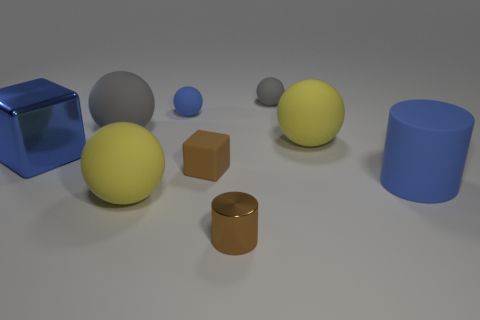There is a gray rubber object right of the big ball behind the big yellow thing that is on the right side of the tiny gray rubber thing; what shape is it?
Give a very brief answer. Sphere. There is a big thing that is right of the tiny blue object and behind the large blue cylinder; what is its shape?
Offer a terse response. Sphere. Is there a large brown cube made of the same material as the big blue cylinder?
Your answer should be very brief. No. What is the size of the rubber sphere that is the same color as the metal cube?
Provide a succinct answer. Small. The cylinder that is on the right side of the small gray matte thing is what color?
Offer a terse response. Blue. Is the shape of the big shiny object the same as the yellow rubber thing right of the tiny gray sphere?
Offer a very short reply. No. Are there any small blocks of the same color as the big metal object?
Make the answer very short. No. There is a brown cylinder that is made of the same material as the large blue cube; what size is it?
Provide a short and direct response. Small. Is the big matte cylinder the same color as the large metal block?
Your answer should be compact. Yes. There is a yellow rubber thing behind the big metal cube; is its shape the same as the big gray rubber object?
Your answer should be very brief. Yes. 